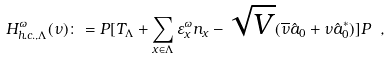<formula> <loc_0><loc_0><loc_500><loc_500>H _ { h . c . , \Lambda } ^ { \omega } ( \nu ) \colon = P [ T _ { \Lambda } + \sum _ { x \in \Lambda } \varepsilon _ { x } ^ { \omega } n _ { x } - \sqrt { V } ( \overline { \nu } \hat { a } _ { 0 } + \nu \hat { a } _ { 0 } ^ { * } ) ] P \ , \</formula> 